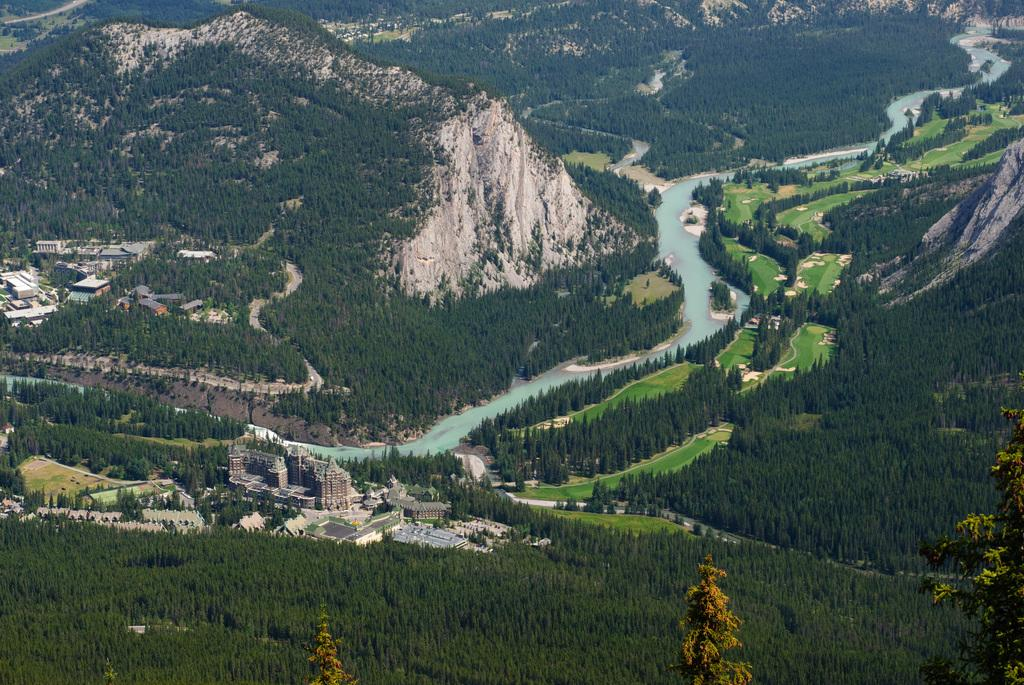What type of natural features can be seen in the image? There are trees and mountains in the image. What type of man-made structures are present in the image? There are buildings in the image. What can be seen in the image that is related to water? There is water visible in the image. What type of insurance policy is being discussed in the image? There is no discussion of insurance policies in the image; it features trees, mountains, buildings, and water. What color is the skirt worn by the person in the image? There is no person wearing a skirt in the image. 